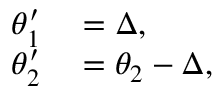<formula> <loc_0><loc_0><loc_500><loc_500>\begin{array} { r l } { \theta _ { 1 } ^ { \prime } } & = \Delta , } \\ { \theta _ { 2 } ^ { \prime } } & = \theta _ { 2 } - \Delta , } \end{array}</formula> 